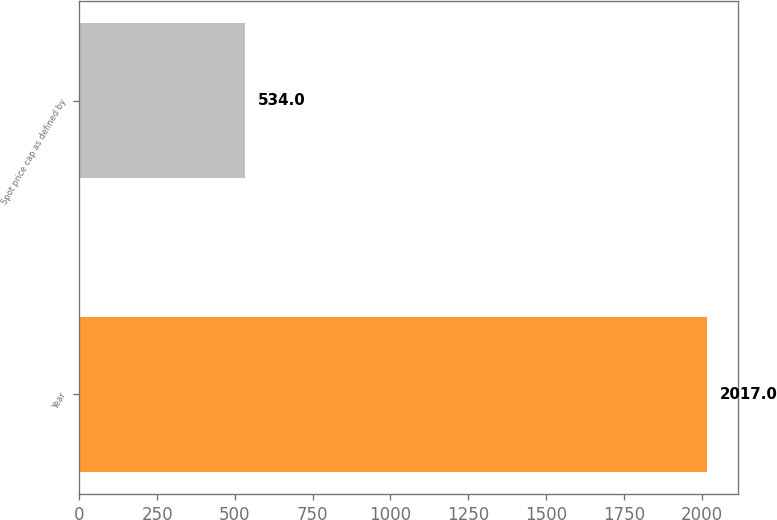Convert chart. <chart><loc_0><loc_0><loc_500><loc_500><bar_chart><fcel>Year<fcel>Spot price cap as defined by<nl><fcel>2017<fcel>534<nl></chart> 